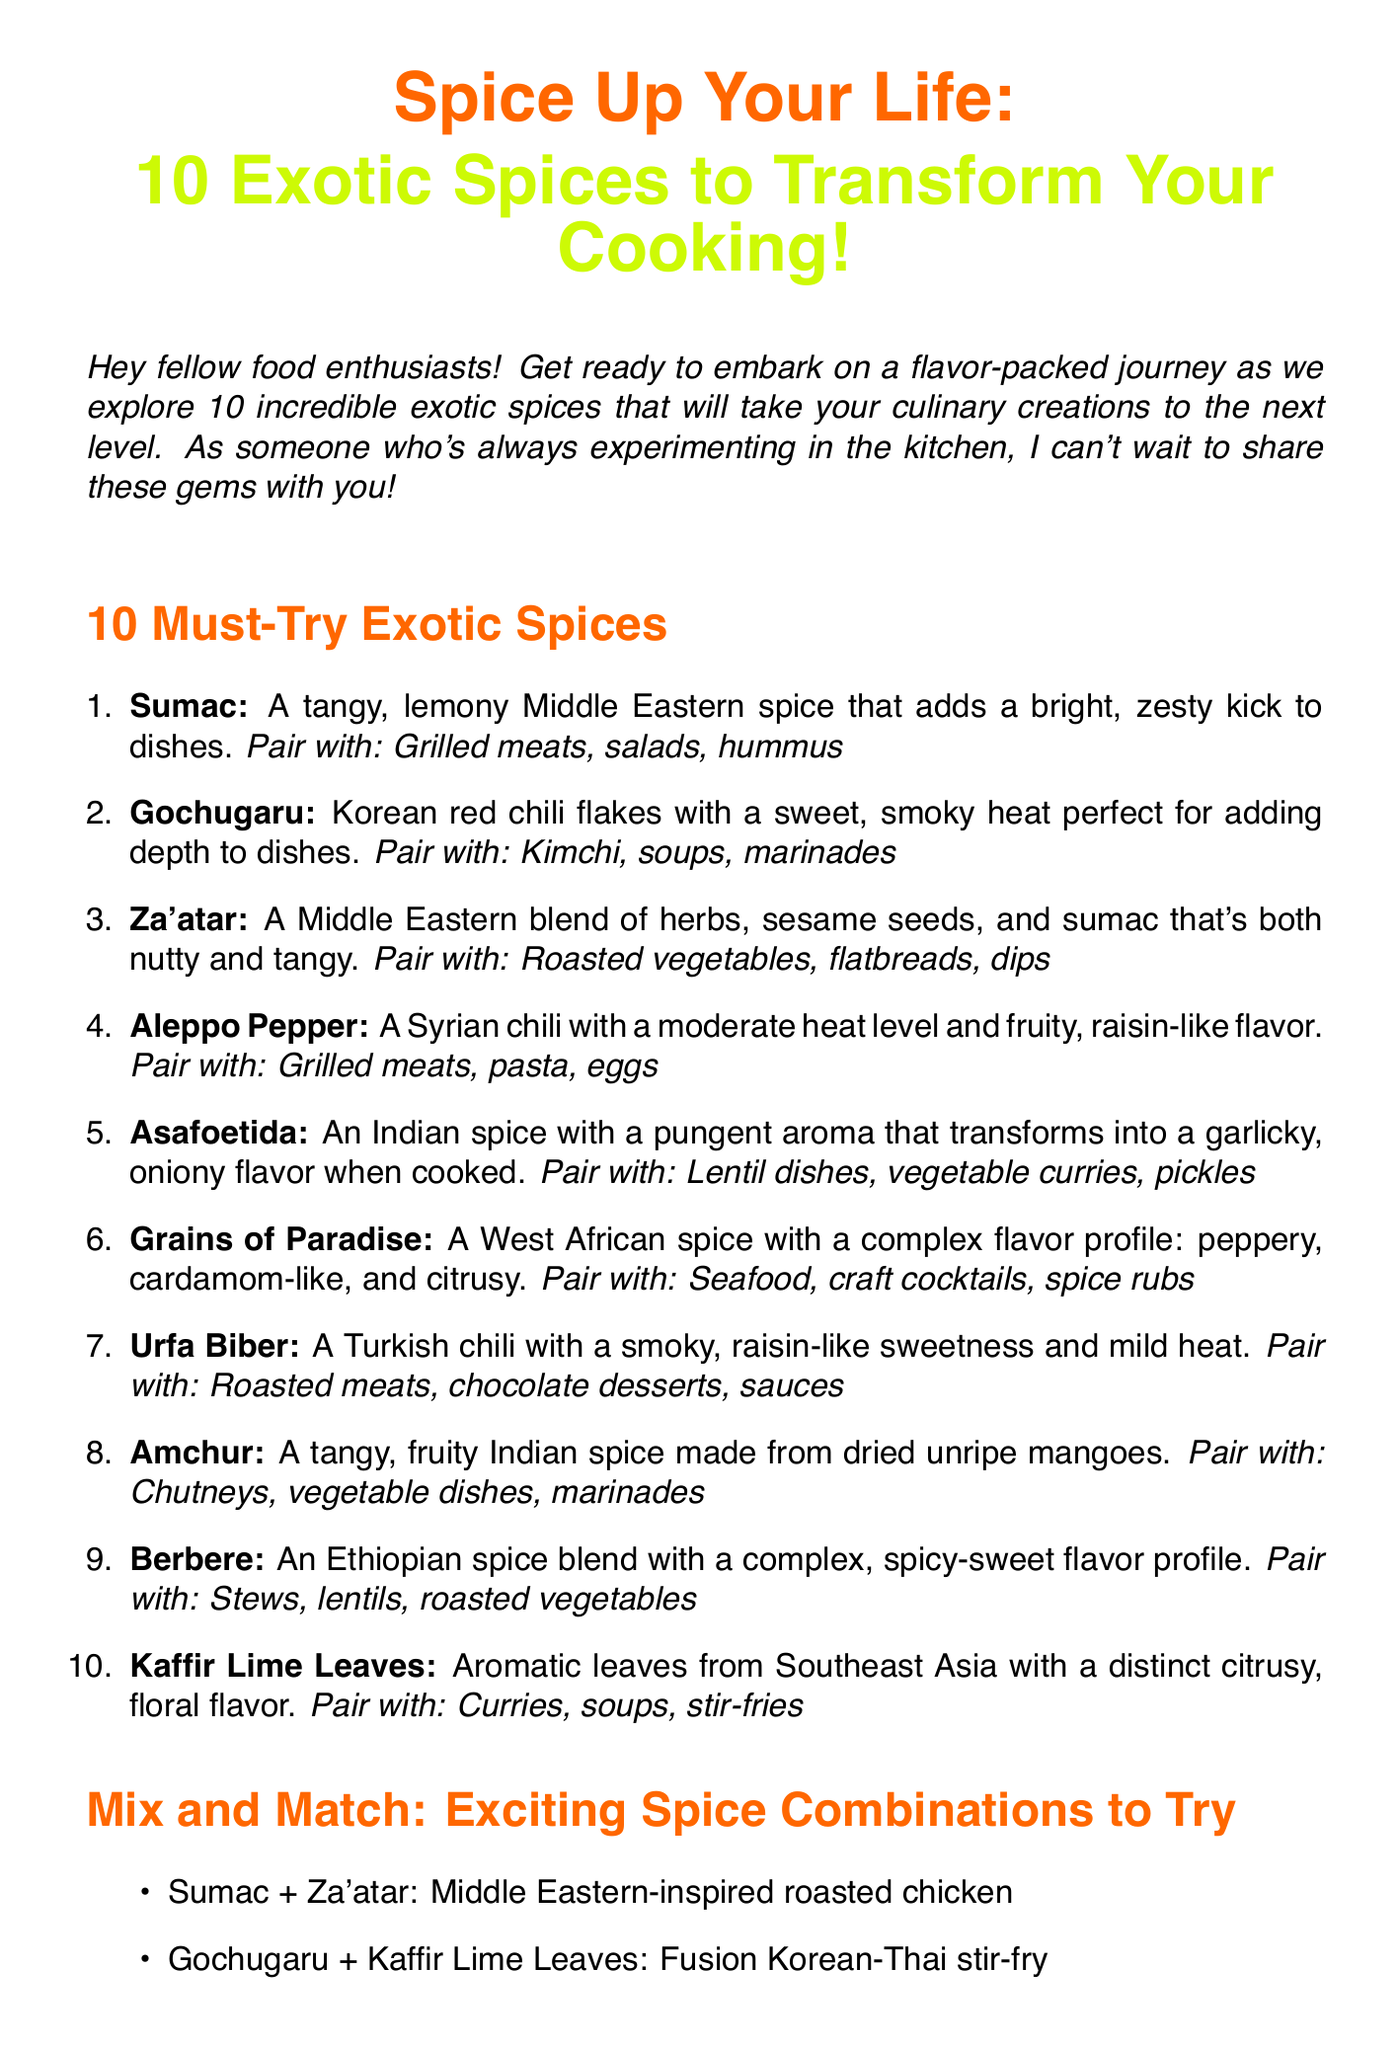What is the title of the newsletter? The title of the newsletter is presented at the top in bold.
Answer: Spice Up Your Life: 10 Exotic Spices to Transform Your Cooking! How many exotic spices are featured in the newsletter? The document lists a total of 10 exotic spices in the section titled "10 Must-Try Exotic Spices."
Answer: 10 Which spice is described as having a tangy, lemony flavor? The description of the spice that adds a bright, zesty kick indicates its tangy, lemony flavor.
Answer: Sumac What is a suggested dish to pair with Gochugaru? The pairing suggestions for Gochugaru can be found in its corresponding description.
Answer: Kimchi Which two spices are suggested for a fusion dish? The combination of spices for a fusion dish can be found in the "Mix and Match" section of the newsletter.
Answer: Gochugaru and Kaffir Lime Leaves What personal experience does the author share about Urfa Biber? The author describes a memorable experience associated with Urfa Biber that sparked their interest in cooking.
Answer: Sprinkling it over homemade chocolate truffles What color is used to highlight the newsletter's title? The color specified for the title is visually prominent in the document.
Answer: Spicy orange What is the call to action at the end of the newsletter? The call to action encourages readers to interact using a specific hashtag which can be found at the end of the document.
Answer: Share your exotic spice adventures with me using #SpicyFoodieTales 